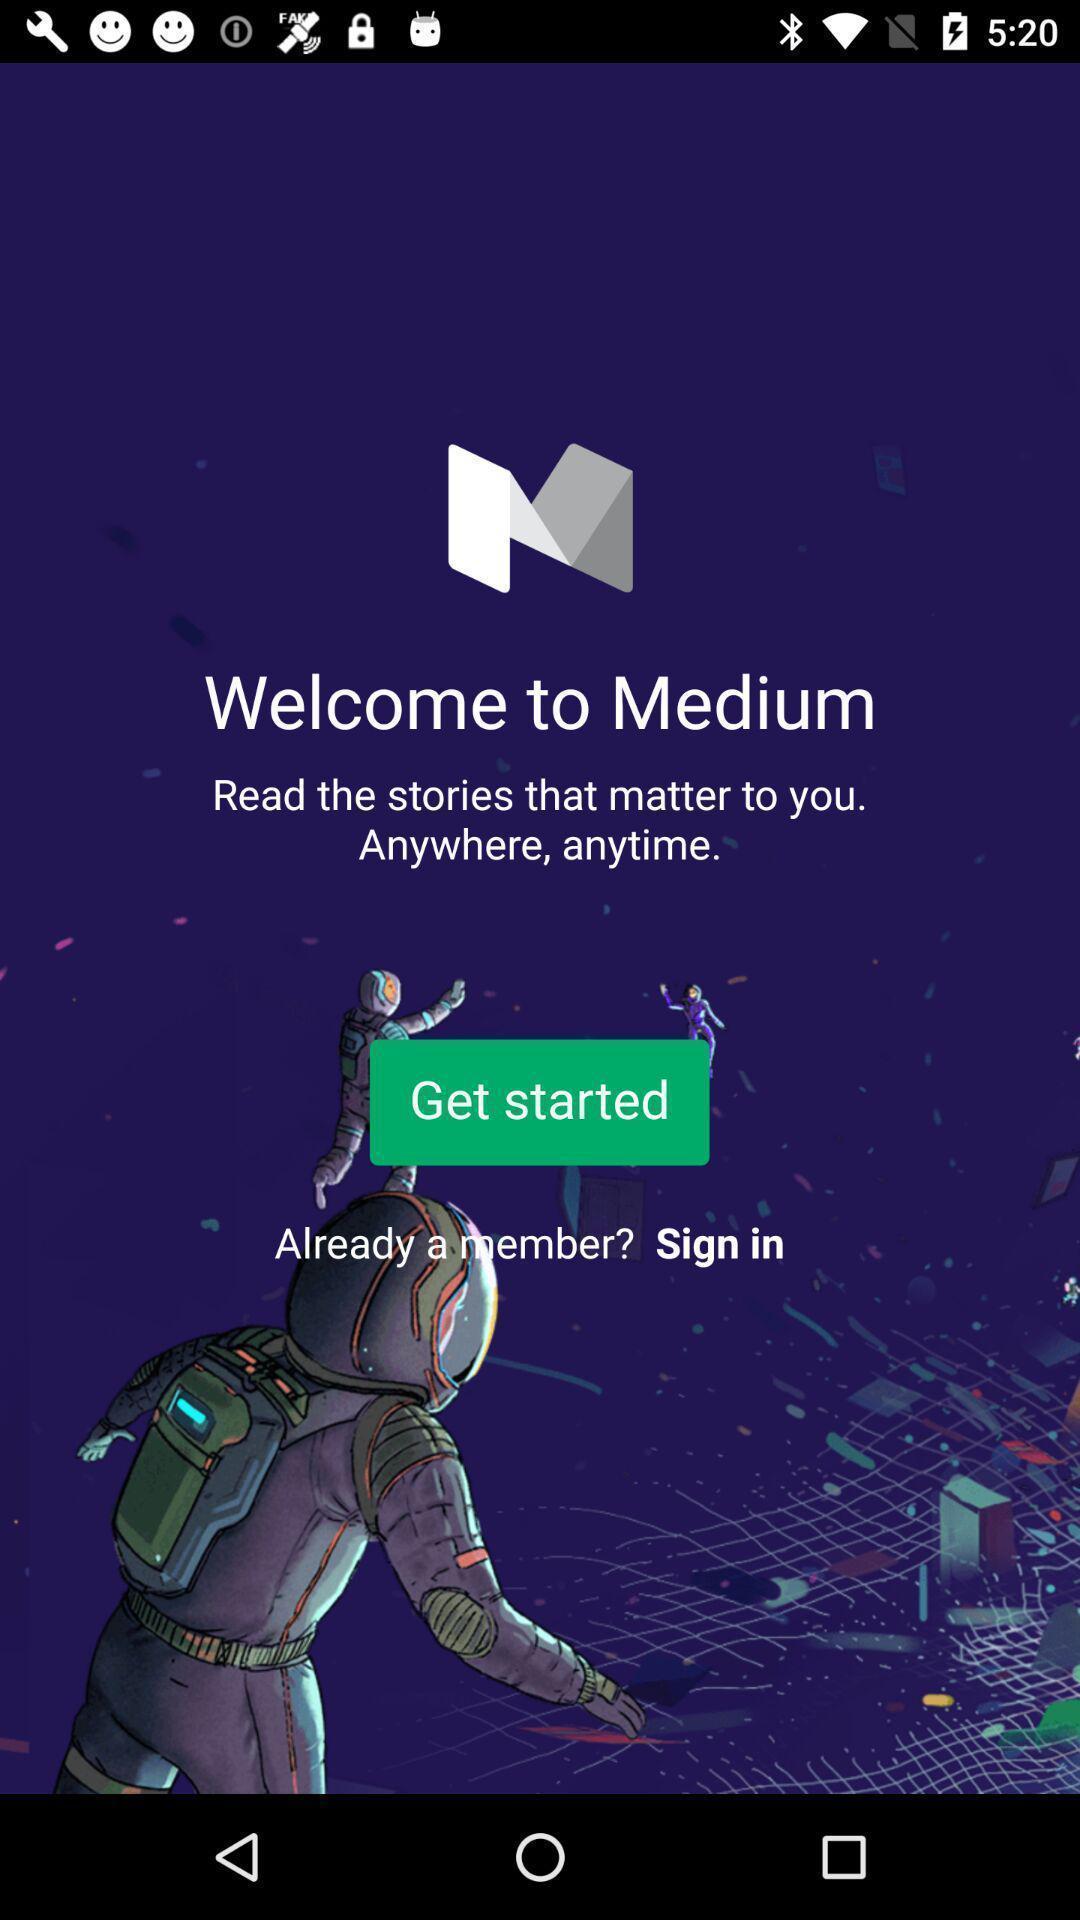What is the overall content of this screenshot? Welcome page for a news feed app. 